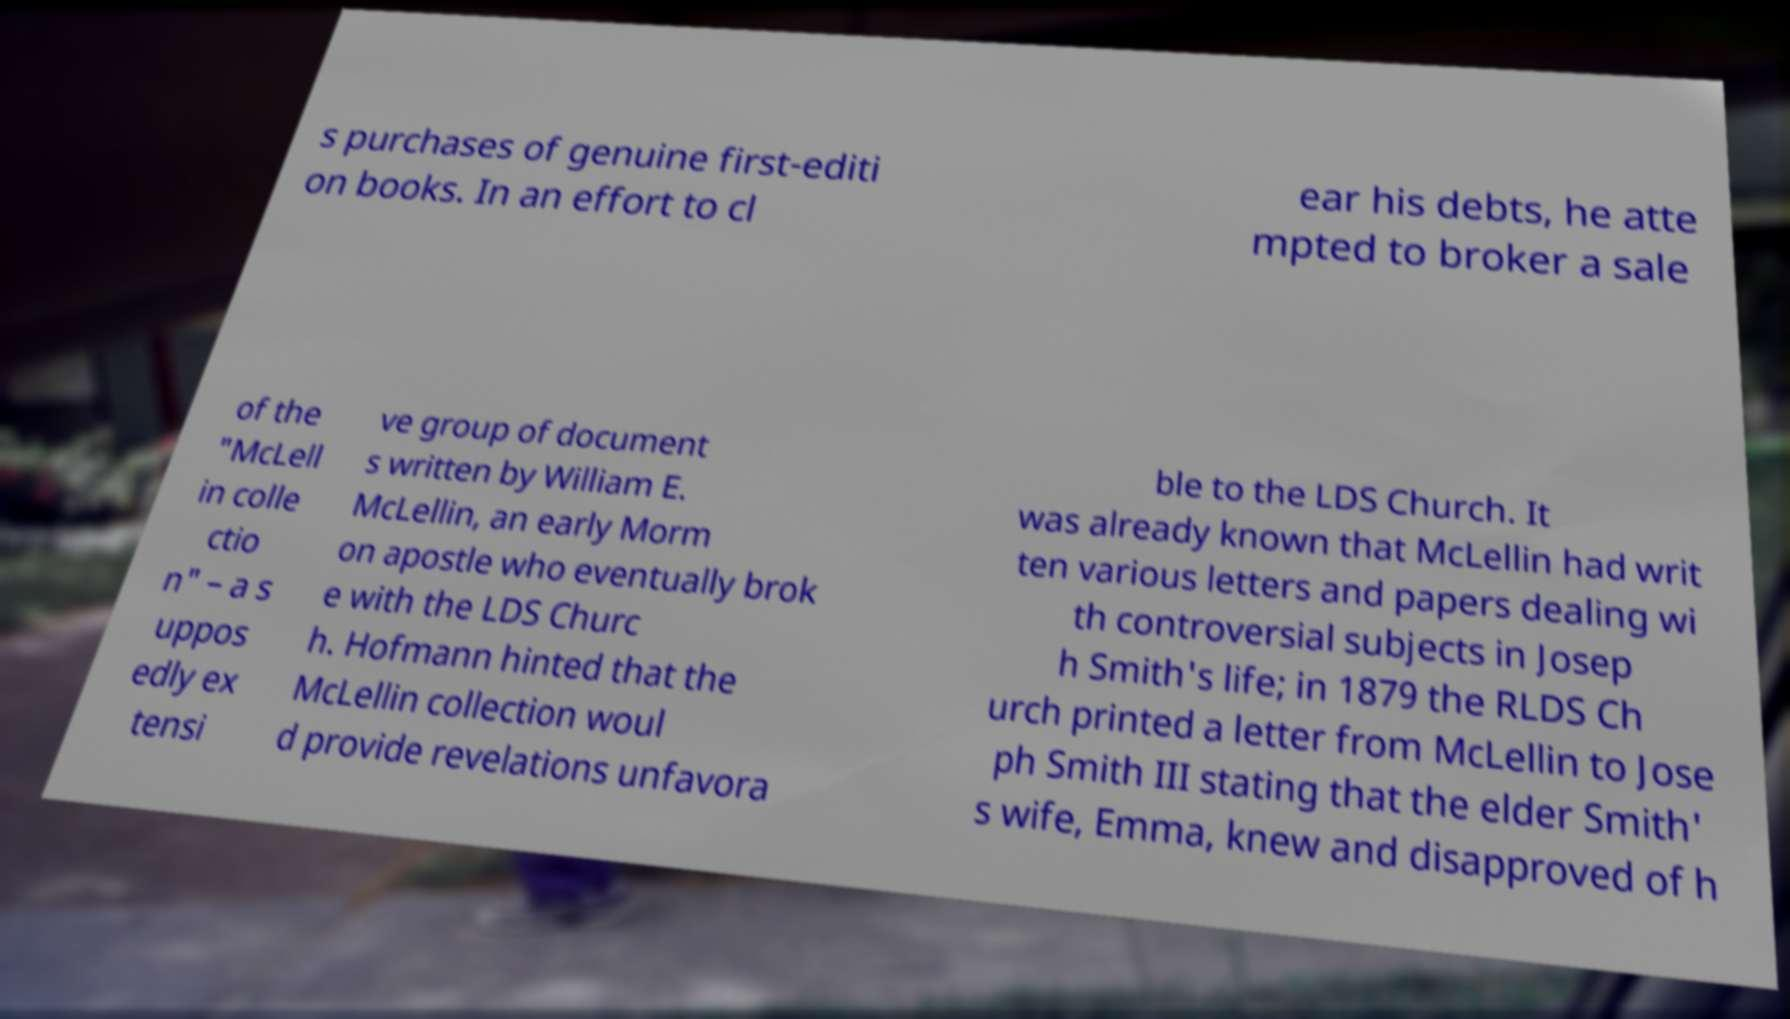Please identify and transcribe the text found in this image. s purchases of genuine first-editi on books. In an effort to cl ear his debts, he atte mpted to broker a sale of the "McLell in colle ctio n" – a s uppos edly ex tensi ve group of document s written by William E. McLellin, an early Morm on apostle who eventually brok e with the LDS Churc h. Hofmann hinted that the McLellin collection woul d provide revelations unfavora ble to the LDS Church. It was already known that McLellin had writ ten various letters and papers dealing wi th controversial subjects in Josep h Smith's life; in 1879 the RLDS Ch urch printed a letter from McLellin to Jose ph Smith III stating that the elder Smith' s wife, Emma, knew and disapproved of h 